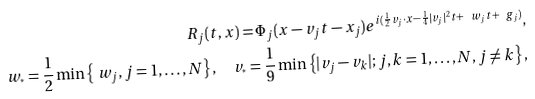Convert formula to latex. <formula><loc_0><loc_0><loc_500><loc_500>R _ { j } ( t , x ) = \Phi _ { j } ( x - v _ { j } t - x _ { j } ) e ^ { i ( \frac { 1 } { 2 } v _ { j } \cdot x - \frac { 1 } { 4 } | v _ { j } | ^ { 2 } t + \ w _ { j } t + \ g _ { j } ) } , \\ \ w _ { ^ { * } } = \frac { 1 } { 2 } \min \left \{ \ w _ { j } , j = 1 , \dots , N \right \} , \quad v _ { ^ { * } } = \frac { 1 } { 9 } \min \left \{ | v _ { j } - v _ { k } | ; j , k = 1 , \dots , N , j \neq k \right \} ,</formula> 